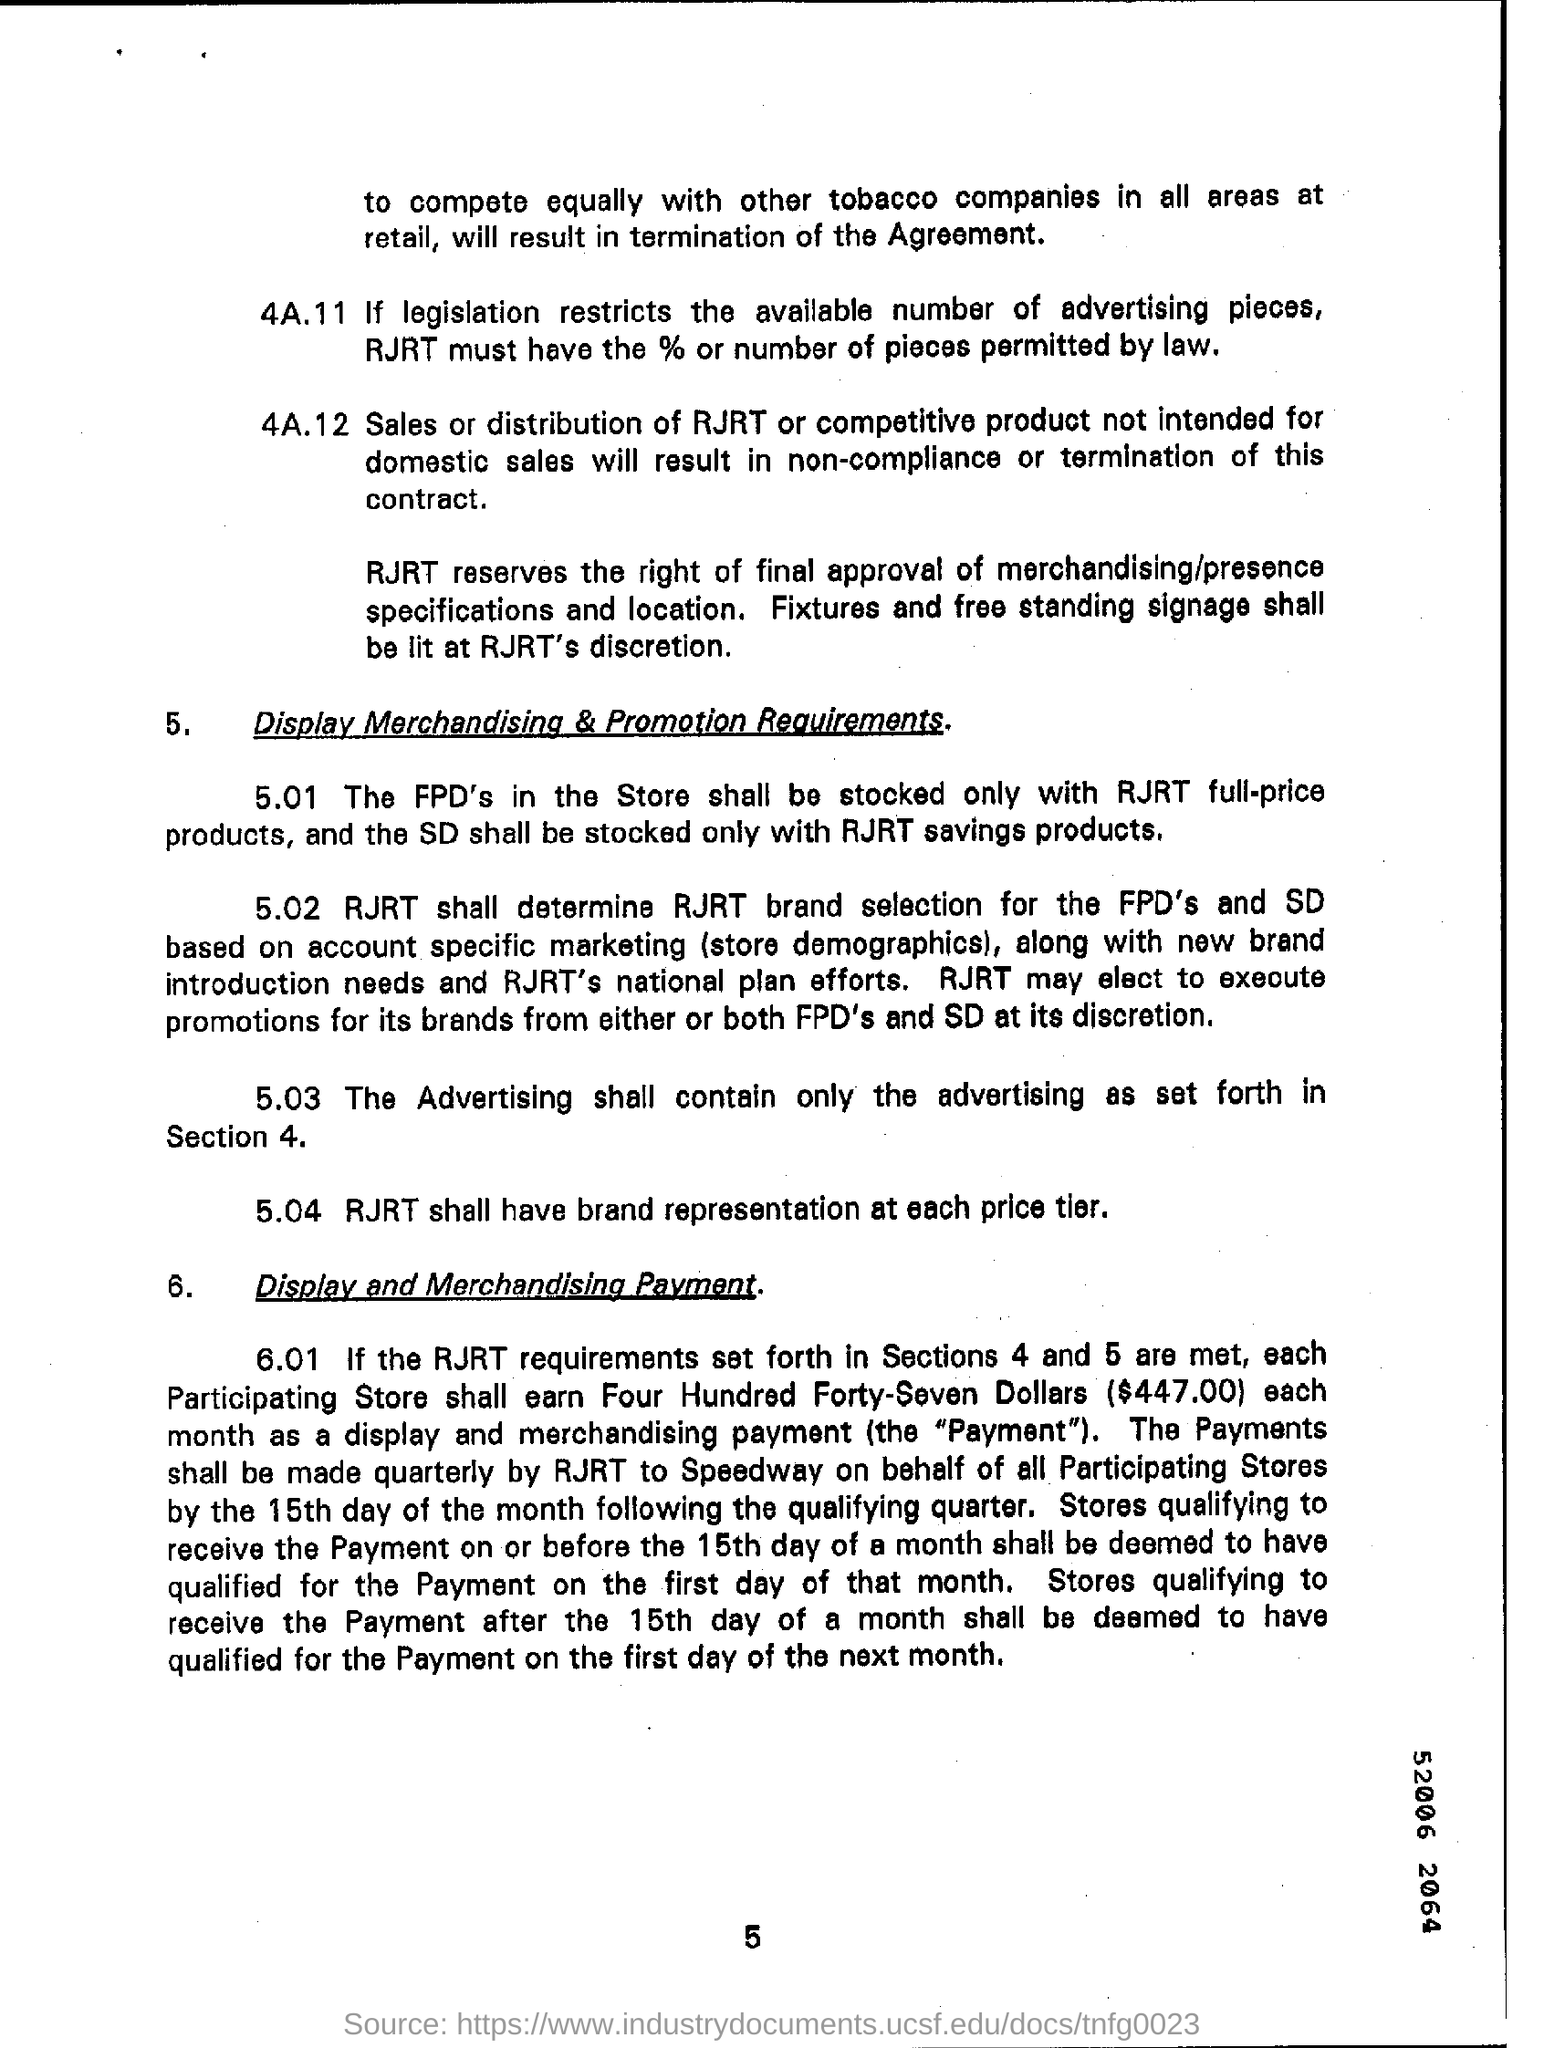What is the page number written on the bottom?
Ensure brevity in your answer.  5. 